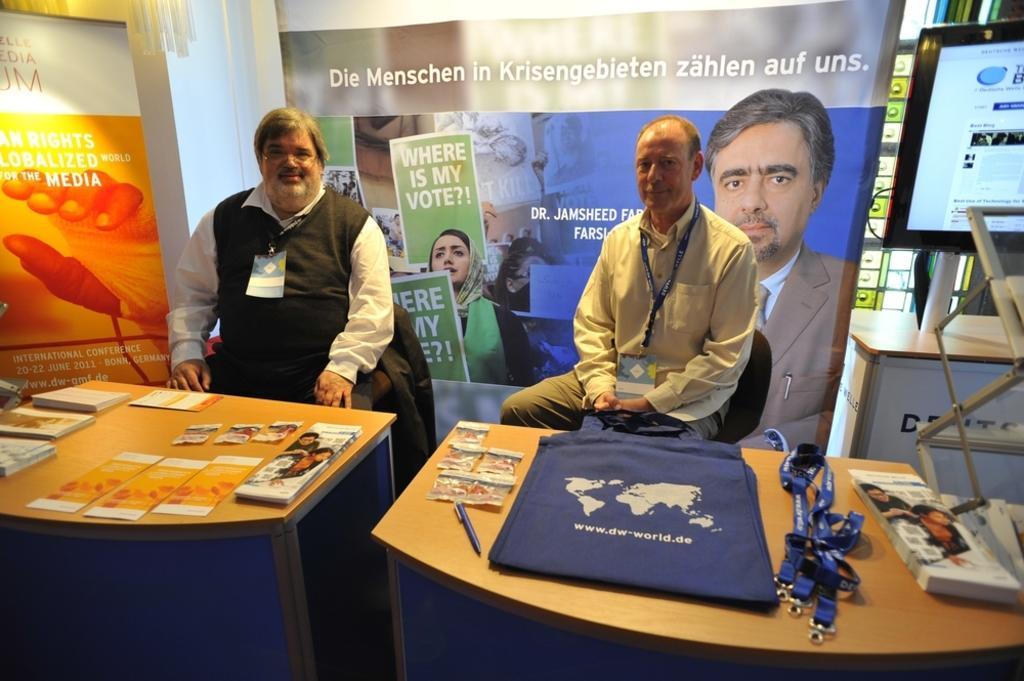In one or two sentences, can you explain what this image depicts? In this picture we have two persons sitting on the chairs, they have two tables in front of them with some tags, a bag, pens, brochure. In the background we have banners and a table. 